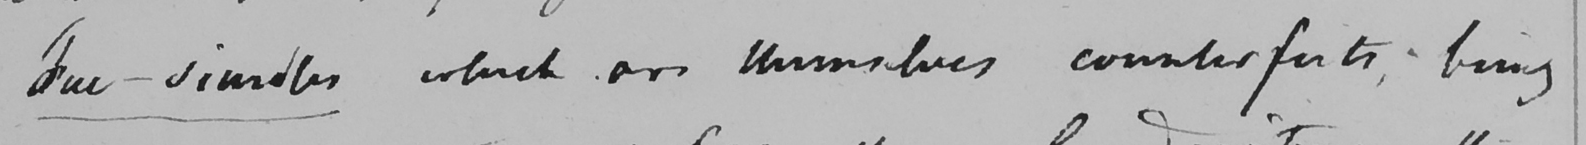What text is written in this handwritten line? Fac-similes which are themselves counterfeits , being 